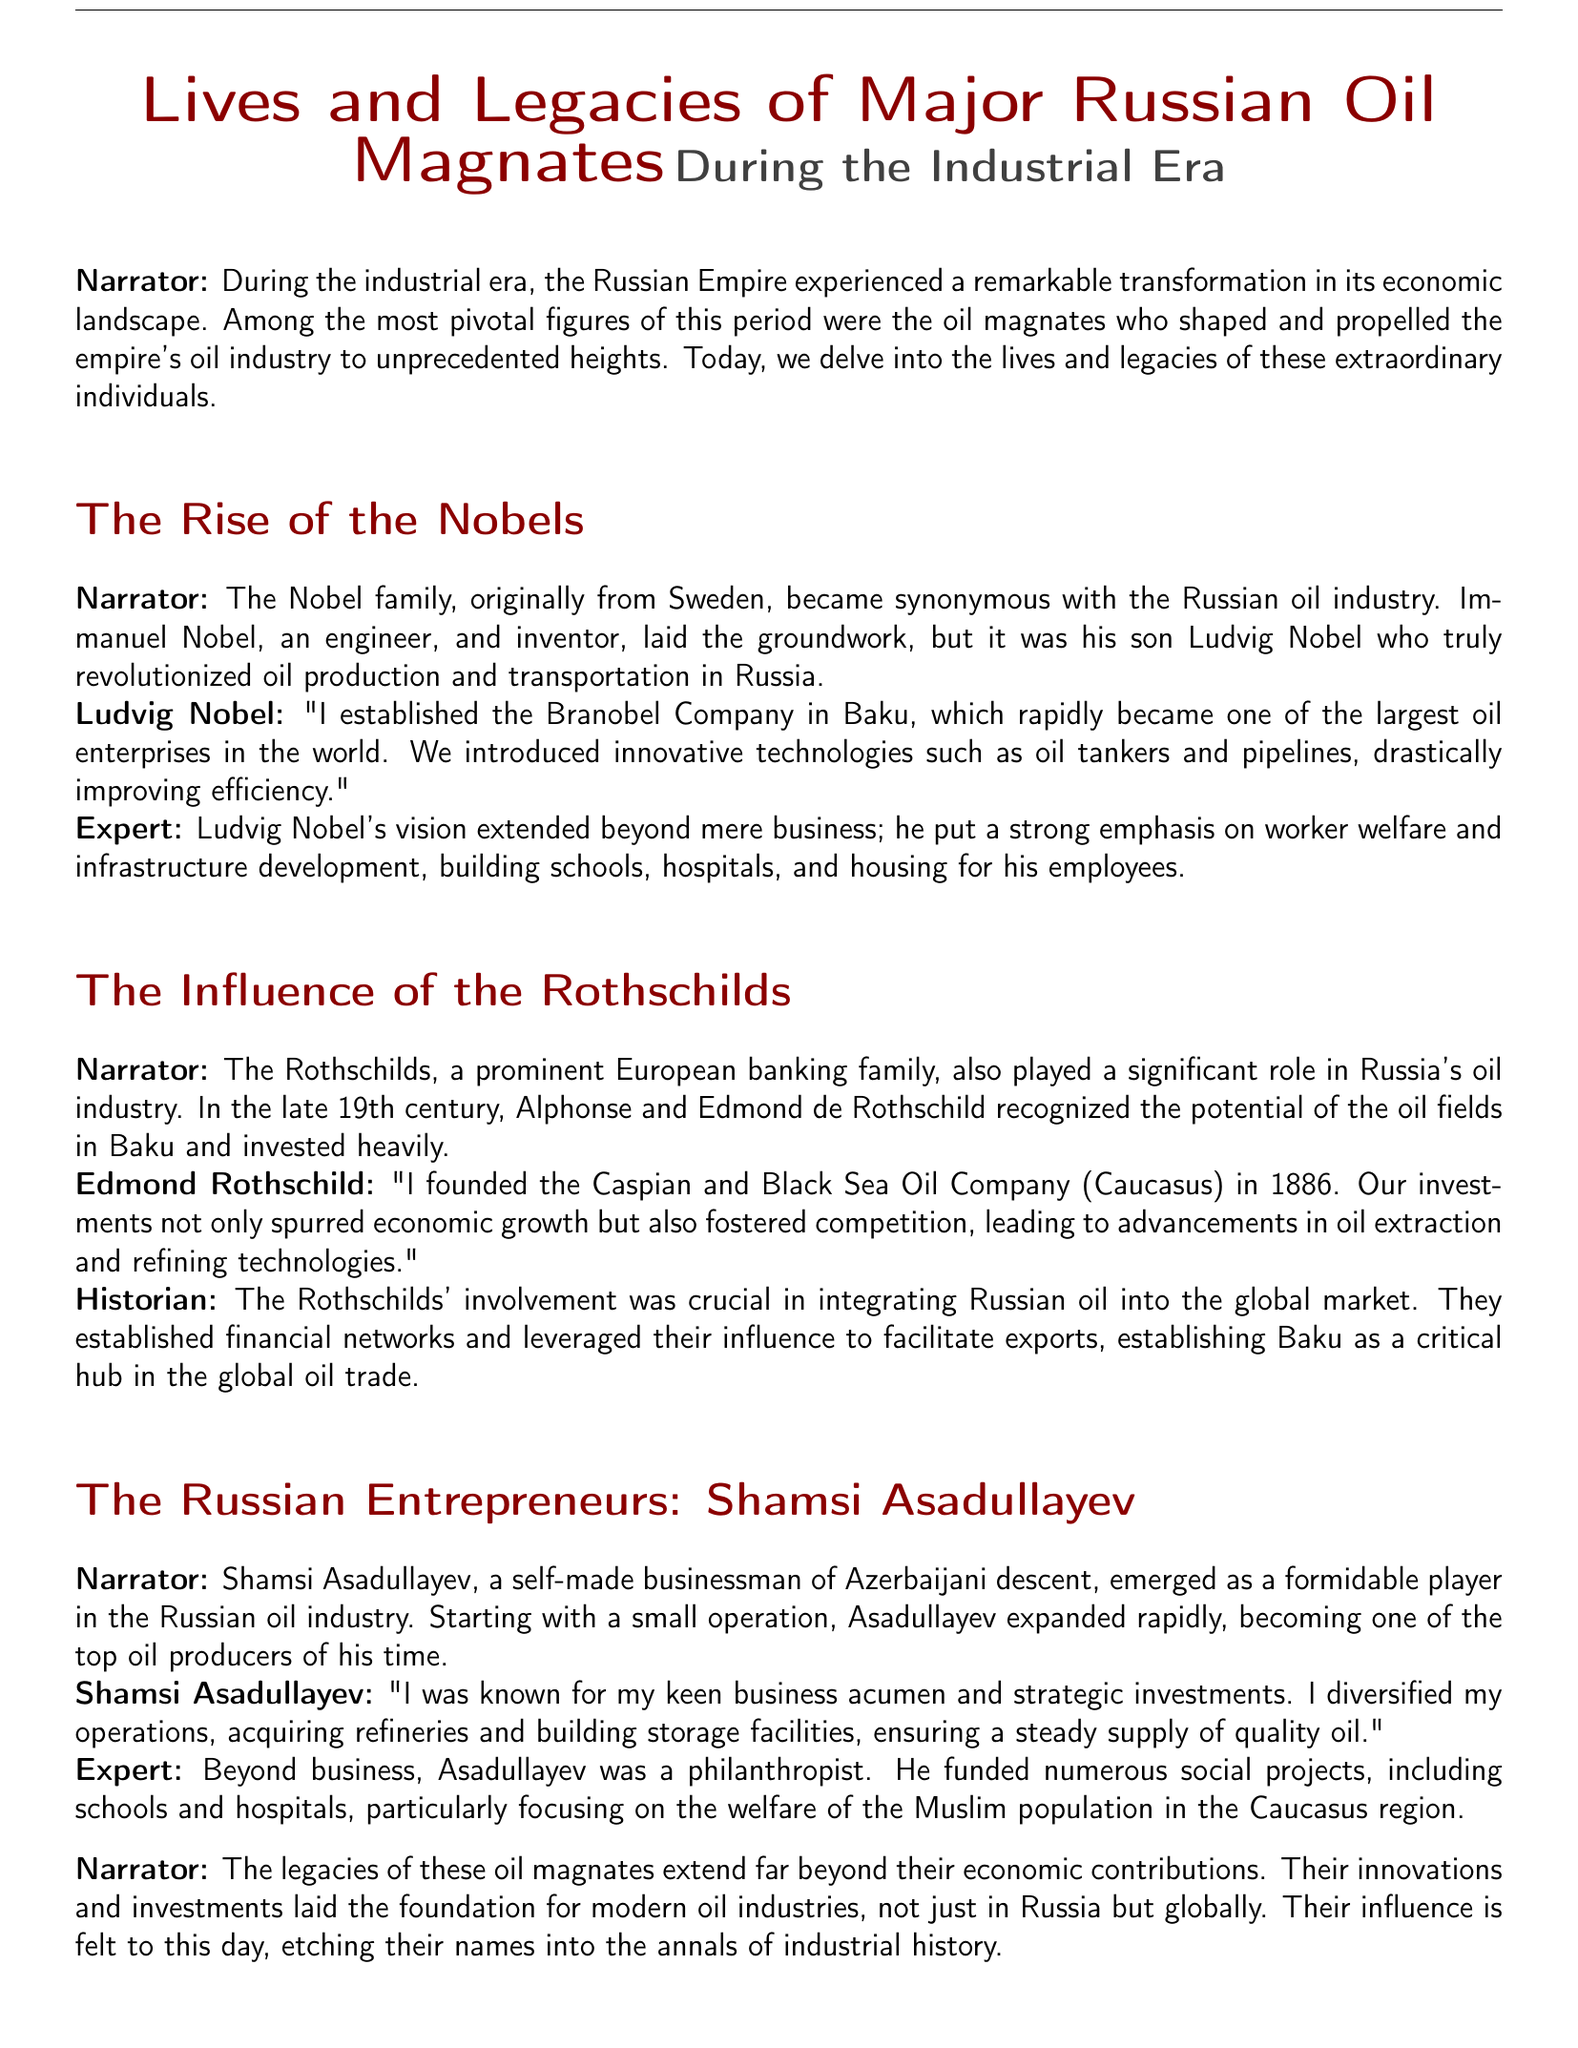What company did Ludvig Nobel establish? The document states that Ludvig Nobel established the Branobel Company in Baku, which became a major oil enterprise.
Answer: Branobel Company Who recognized the potential of the oil fields in Baku? The transcript mentions that Alphonse and Edmond de Rothschild recognized the potential of the oil fields in Baku.
Answer: Alphonse and Edmond de Rothschild What year was the Caspian and Black Sea Oil Company founded? According to Edmond Rothschild, he founded the Caspian and Black Sea Oil Company in 1886.
Answer: 1886 Which industry did Shamsi Asadullayev emerge as a player in? The document indicates that Shamsi Asadullayev emerged as a formidable player in the Russian oil industry.
Answer: Russian oil industry What is a significant aspect of Ludvig Nobel’s vision beyond business? The transcript mentions that Ludvig Nobel put a strong emphasis on worker welfare and infrastructure development.
Answer: Worker welfare and infrastructure development What type of projects did Shamsi Asadullayev fund? The document specifies that Shamsi Asadullayev funded numerous social projects, including schools and hospitals.
Answer: Social projects What legacy did these oil magnates leave behind? The narrator notes that their innovations and investments laid the foundation for modern oil industries globally.
Answer: Foundation for modern oil industries What nationality was Shamsi Asadullayev? The transcript identifies Shamsi Asadullayev as being of Azerbaijani descent.
Answer: Azerbaijani What was the focus of Shamsi Asadullayev's philanthropy? The document details that Asadullayev focused on the welfare of the Muslim population in the Caucasus region.
Answer: Welfare of the Muslim population 